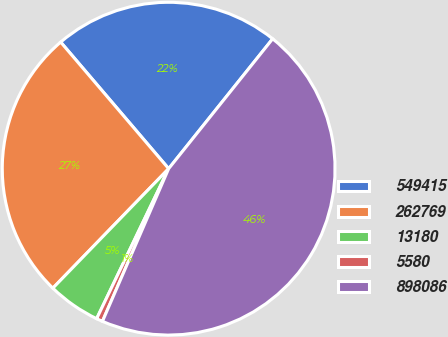Convert chart. <chart><loc_0><loc_0><loc_500><loc_500><pie_chart><fcel>549415<fcel>262769<fcel>13180<fcel>5580<fcel>898086<nl><fcel>21.99%<fcel>26.51%<fcel>5.13%<fcel>0.61%<fcel>45.77%<nl></chart> 